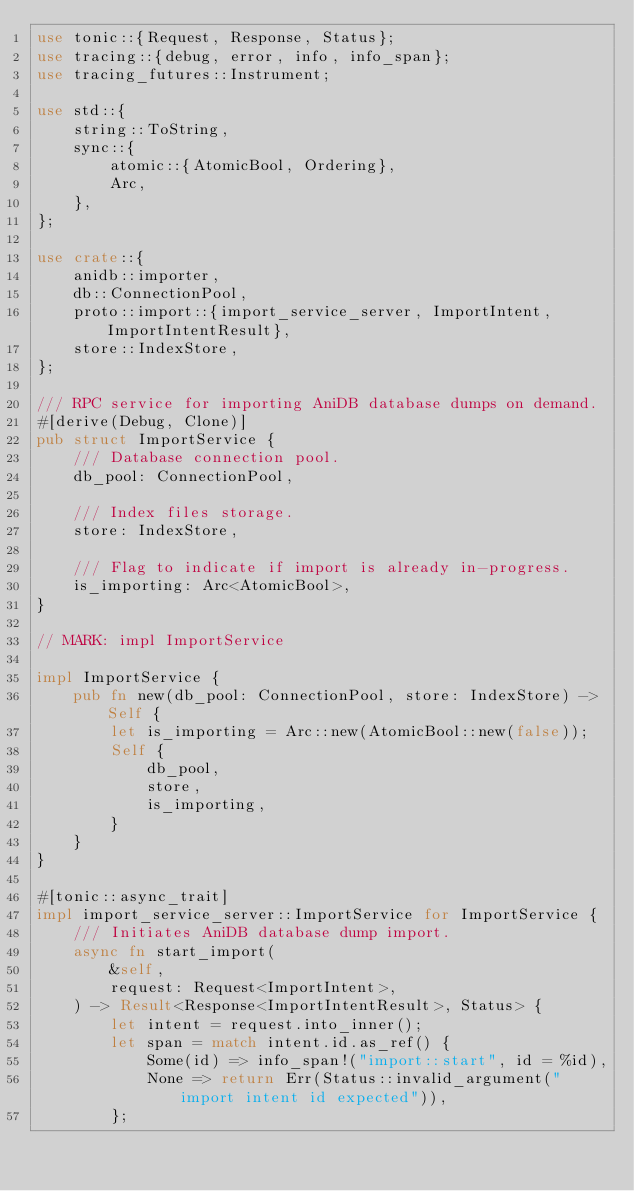<code> <loc_0><loc_0><loc_500><loc_500><_Rust_>use tonic::{Request, Response, Status};
use tracing::{debug, error, info, info_span};
use tracing_futures::Instrument;

use std::{
    string::ToString,
    sync::{
        atomic::{AtomicBool, Ordering},
        Arc,
    },
};

use crate::{
    anidb::importer,
    db::ConnectionPool,
    proto::import::{import_service_server, ImportIntent, ImportIntentResult},
    store::IndexStore,
};

/// RPC service for importing AniDB database dumps on demand.
#[derive(Debug, Clone)]
pub struct ImportService {
    /// Database connection pool.
    db_pool: ConnectionPool,

    /// Index files storage.
    store: IndexStore,

    /// Flag to indicate if import is already in-progress.
    is_importing: Arc<AtomicBool>,
}

// MARK: impl ImportService

impl ImportService {
    pub fn new(db_pool: ConnectionPool, store: IndexStore) -> Self {
        let is_importing = Arc::new(AtomicBool::new(false));
        Self {
            db_pool,
            store,
            is_importing,
        }
    }
}

#[tonic::async_trait]
impl import_service_server::ImportService for ImportService {
    /// Initiates AniDB database dump import.
    async fn start_import(
        &self,
        request: Request<ImportIntent>,
    ) -> Result<Response<ImportIntentResult>, Status> {
        let intent = request.into_inner();
        let span = match intent.id.as_ref() {
            Some(id) => info_span!("import::start", id = %id),
            None => return Err(Status::invalid_argument("import intent id expected")),
        };</code> 